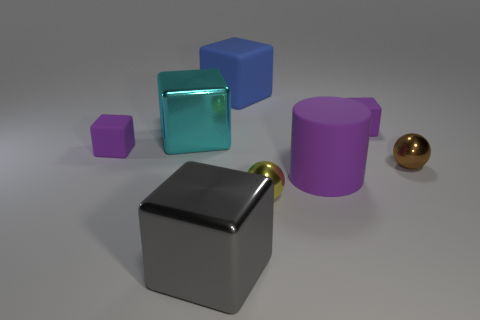Subtract all large blue blocks. How many blocks are left? 4 Add 1 big brown blocks. How many objects exist? 9 Subtract all gray blocks. How many blocks are left? 4 Subtract 4 blocks. How many blocks are left? 1 Subtract all cubes. How many objects are left? 3 Subtract all gray cubes. How many yellow cylinders are left? 0 Add 2 yellow spheres. How many yellow spheres exist? 3 Subtract 0 blue cylinders. How many objects are left? 8 Subtract all green spheres. Subtract all cyan blocks. How many spheres are left? 2 Subtract all big blue blocks. Subtract all big blue things. How many objects are left? 6 